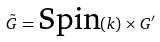Convert formula to latex. <formula><loc_0><loc_0><loc_500><loc_500>\tilde { G } = \text {Spin} ( k ) \times G ^ { \prime }</formula> 